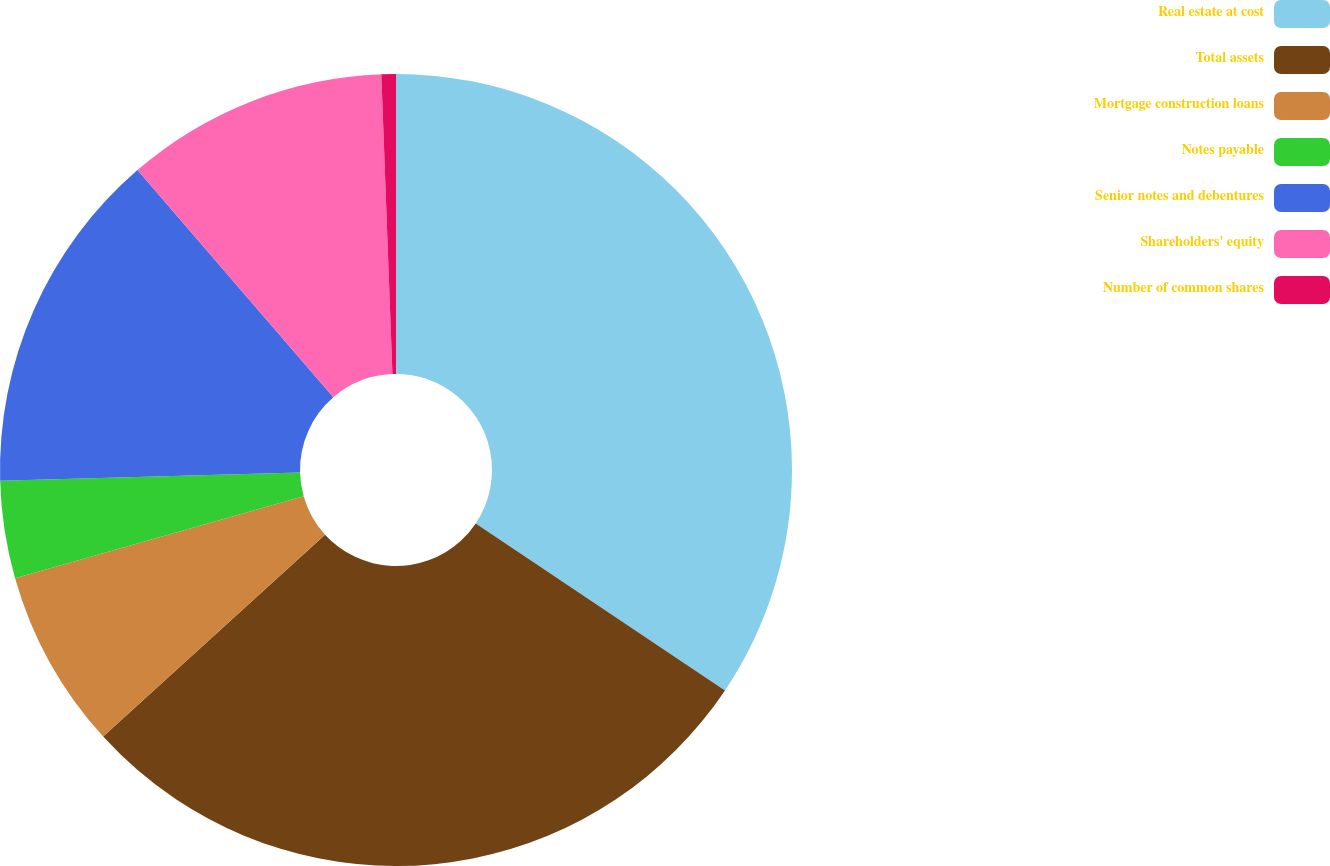<chart> <loc_0><loc_0><loc_500><loc_500><pie_chart><fcel>Real estate at cost<fcel>Total assets<fcel>Mortgage construction loans<fcel>Notes payable<fcel>Senior notes and debentures<fcel>Shareholders' equity<fcel>Number of common shares<nl><fcel>34.39%<fcel>28.85%<fcel>7.35%<fcel>3.97%<fcel>14.11%<fcel>10.73%<fcel>0.59%<nl></chart> 